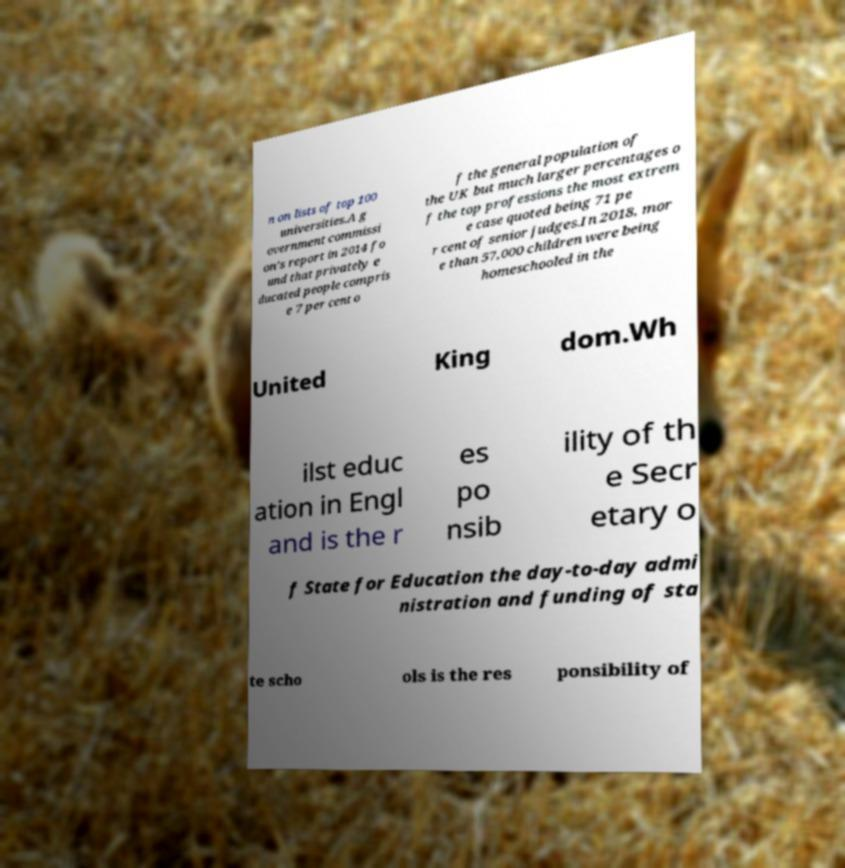Please read and relay the text visible in this image. What does it say? n on lists of top 100 universities.A g overnment commissi on's report in 2014 fo und that privately e ducated people compris e 7 per cent o f the general population of the UK but much larger percentages o f the top professions the most extrem e case quoted being 71 pe r cent of senior judges.In 2018, mor e than 57,000 children were being homeschooled in the United King dom.Wh ilst educ ation in Engl and is the r es po nsib ility of th e Secr etary o f State for Education the day-to-day admi nistration and funding of sta te scho ols is the res ponsibility of 